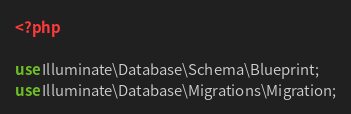<code> <loc_0><loc_0><loc_500><loc_500><_PHP_><?php

use Illuminate\Database\Schema\Blueprint;
use Illuminate\Database\Migrations\Migration;
</code> 